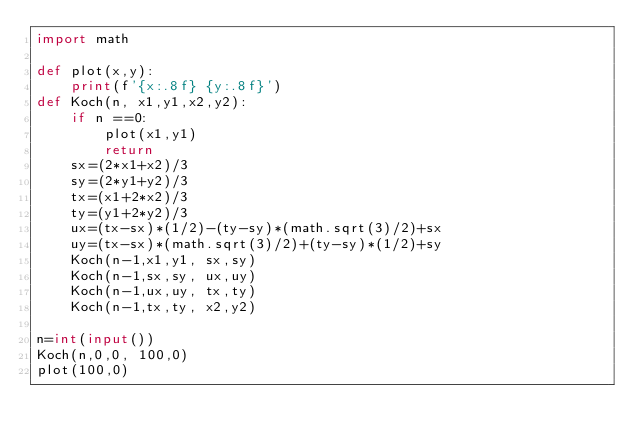<code> <loc_0><loc_0><loc_500><loc_500><_Python_>import math

def plot(x,y):
    print(f'{x:.8f} {y:.8f}')
def Koch(n, x1,y1,x2,y2):
    if n ==0:
        plot(x1,y1)
        return
    sx=(2*x1+x2)/3
    sy=(2*y1+y2)/3
    tx=(x1+2*x2)/3
    ty=(y1+2*y2)/3
    ux=(tx-sx)*(1/2)-(ty-sy)*(math.sqrt(3)/2)+sx
    uy=(tx-sx)*(math.sqrt(3)/2)+(ty-sy)*(1/2)+sy
    Koch(n-1,x1,y1, sx,sy)
    Koch(n-1,sx,sy, ux,uy)
    Koch(n-1,ux,uy, tx,ty)
    Koch(n-1,tx,ty, x2,y2)
   
n=int(input())
Koch(n,0,0, 100,0)
plot(100,0)
</code> 